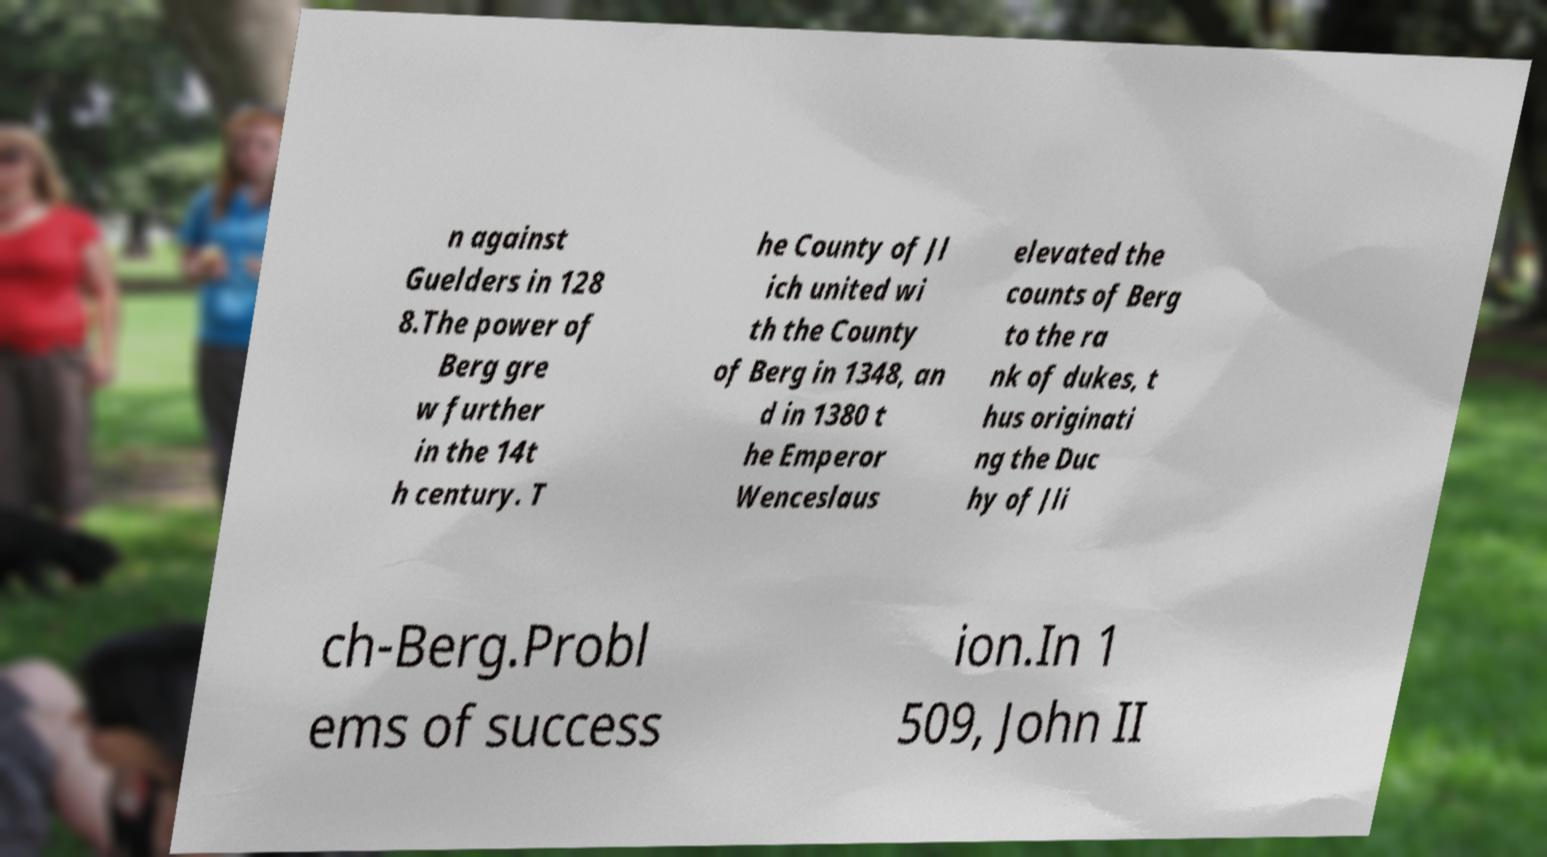Could you assist in decoding the text presented in this image and type it out clearly? n against Guelders in 128 8.The power of Berg gre w further in the 14t h century. T he County of Jl ich united wi th the County of Berg in 1348, an d in 1380 t he Emperor Wenceslaus elevated the counts of Berg to the ra nk of dukes, t hus originati ng the Duc hy of Jli ch-Berg.Probl ems of success ion.In 1 509, John II 